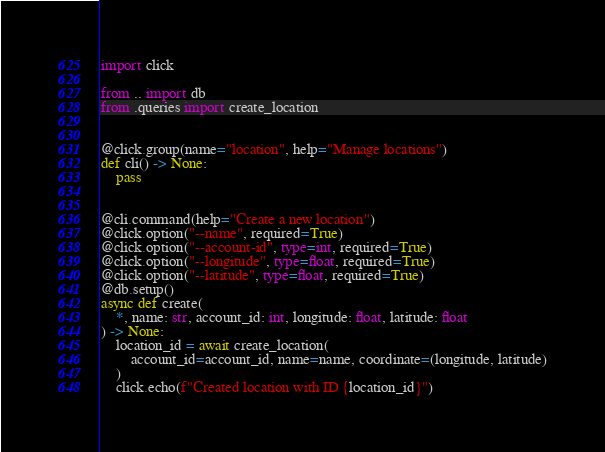Convert code to text. <code><loc_0><loc_0><loc_500><loc_500><_Python_>import click

from .. import db
from .queries import create_location


@click.group(name="location", help="Manage locations")
def cli() -> None:
    pass


@cli.command(help="Create a new location")
@click.option("--name", required=True)
@click.option("--account-id", type=int, required=True)
@click.option("--longitude", type=float, required=True)
@click.option("--latitude", type=float, required=True)
@db.setup()
async def create(
    *, name: str, account_id: int, longitude: float, latitude: float
) -> None:
    location_id = await create_location(
        account_id=account_id, name=name, coordinate=(longitude, latitude)
    )
    click.echo(f"Created location with ID {location_id}")
</code> 